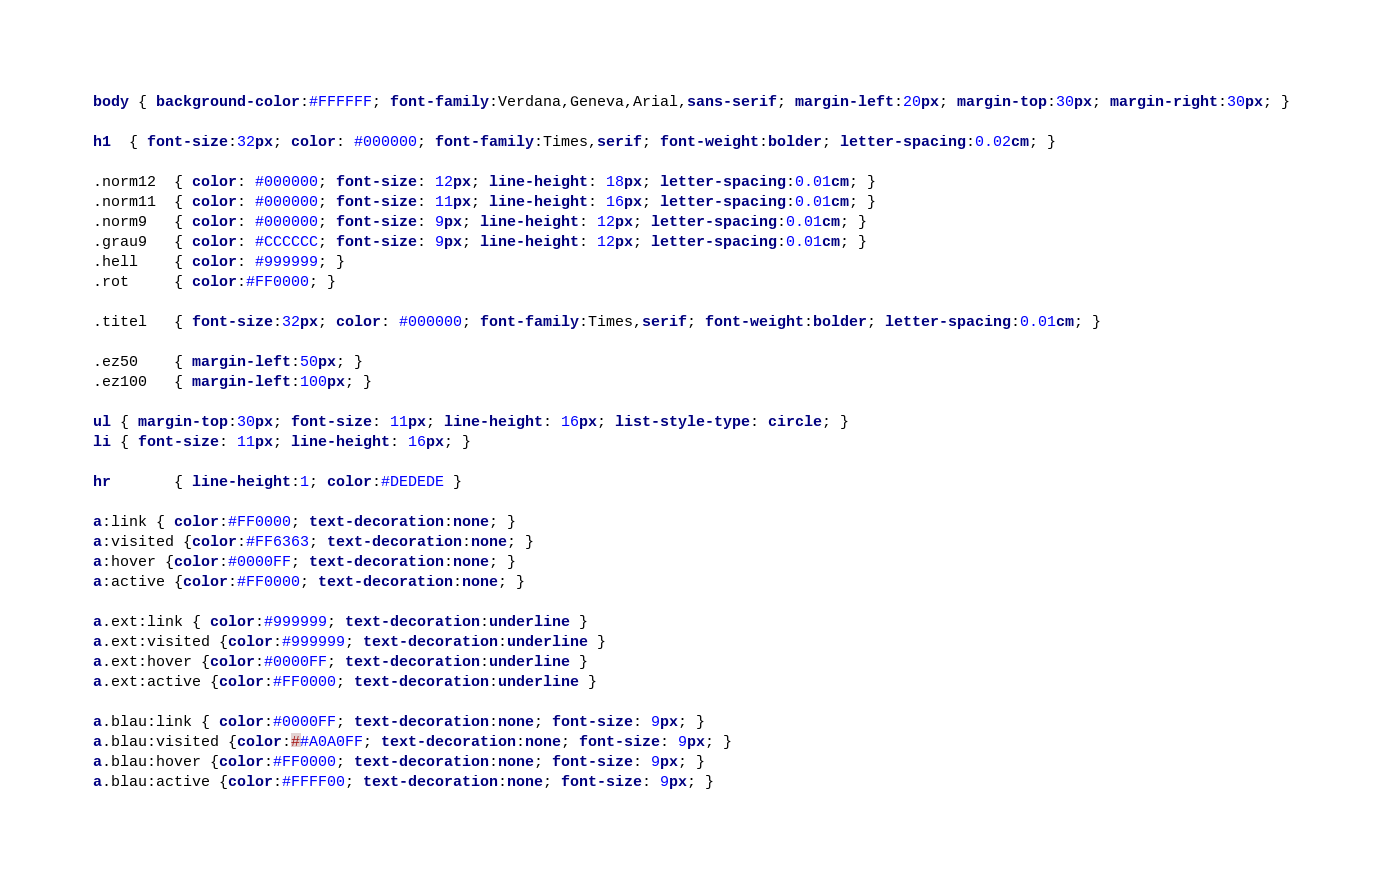Convert code to text. <code><loc_0><loc_0><loc_500><loc_500><_CSS_>body { background-color:#FFFFFF; font-family:Verdana,Geneva,Arial,sans-serif; margin-left:20px; margin-top:30px; margin-right:30px; }

h1  { font-size:32px; color: #000000; font-family:Times,serif; font-weight:bolder; letter-spacing:0.02cm; }

.norm12  { color: #000000; font-size: 12px; line-height: 18px; letter-spacing:0.01cm; }
.norm11  { color: #000000; font-size: 11px; line-height: 16px; letter-spacing:0.01cm; }
.norm9   { color: #000000; font-size: 9px; line-height: 12px; letter-spacing:0.01cm; }
.grau9   { color: #CCCCCC; font-size: 9px; line-height: 12px; letter-spacing:0.01cm; }
.hell    { color: #999999; }
.rot     { color:#FF0000; }

.titel   { font-size:32px; color: #000000; font-family:Times,serif; font-weight:bolder; letter-spacing:0.01cm; }

.ez50    { margin-left:50px; }
.ez100   { margin-left:100px; }

ul { margin-top:30px; font-size: 11px; line-height: 16px; list-style-type: circle; }
li { font-size: 11px; line-height: 16px; }

hr       { line-height:1; color:#DEDEDE }

a:link { color:#FF0000; text-decoration:none; }
a:visited {color:#FF6363; text-decoration:none; }
a:hover {color:#0000FF; text-decoration:none; }
a:active {color:#FF0000; text-decoration:none; }

a.ext:link { color:#999999; text-decoration:underline }
a.ext:visited {color:#999999; text-decoration:underline }
a.ext:hover {color:#0000FF; text-decoration:underline }
a.ext:active {color:#FF0000; text-decoration:underline }

a.blau:link { color:#0000FF; text-decoration:none; font-size: 9px; }
a.blau:visited {color:##A0A0FF; text-decoration:none; font-size: 9px; }
a.blau:hover {color:#FF0000; text-decoration:none; font-size: 9px; }
a.blau:active {color:#FFFF00; text-decoration:none; font-size: 9px; }
</code> 